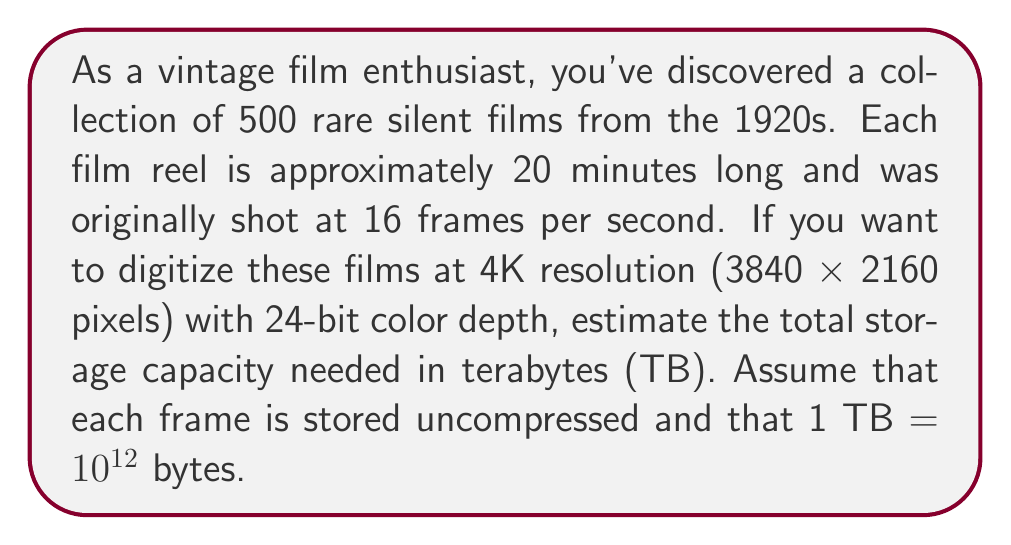What is the answer to this math problem? To solve this problem, let's break it down into steps:

1. Calculate the number of frames per film:
   * Duration of each film: 20 minutes = 1200 seconds
   * Frames per second: 16
   * Frames per film: $1200 \times 16 = 19,200$ frames

2. Calculate the total number of frames for all films:
   * Number of films: 500
   * Total frames: $500 \times 19,200 = 9,600,000$ frames

3. Calculate the size of each frame:
   * Resolution: 3840 x 2160 pixels = 8,294,400 pixels
   * Color depth: 24 bits = 3 bytes per pixel
   * Size per frame: $8,294,400 \times 3 = 24,883,200$ bytes

4. Calculate the total size for all frames:
   * Total size: $9,600,000 \times 24,883,200 = 238,878,720,000,000$ bytes

5. Convert bytes to terabytes:
   * 1 TB = $10^{12}$ bytes
   * TB needed: $\frac{238,878,720,000,000}{10^{12}} = 238.87872$ TB

Therefore, the estimated storage capacity needed is approximately 238.88 TB.
Answer: 238.88 TB 